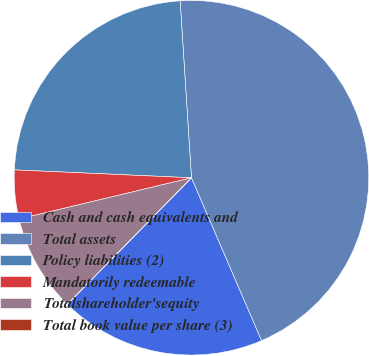Convert chart. <chart><loc_0><loc_0><loc_500><loc_500><pie_chart><fcel>Cash and cash equivalents and<fcel>Total assets<fcel>Policy liabilities (2)<fcel>Mandatorily redeemable<fcel>Totalshareholder'sequity<fcel>Total book value per share (3)<nl><fcel>18.82%<fcel>44.55%<fcel>23.27%<fcel>4.45%<fcel>8.91%<fcel>0.0%<nl></chart> 